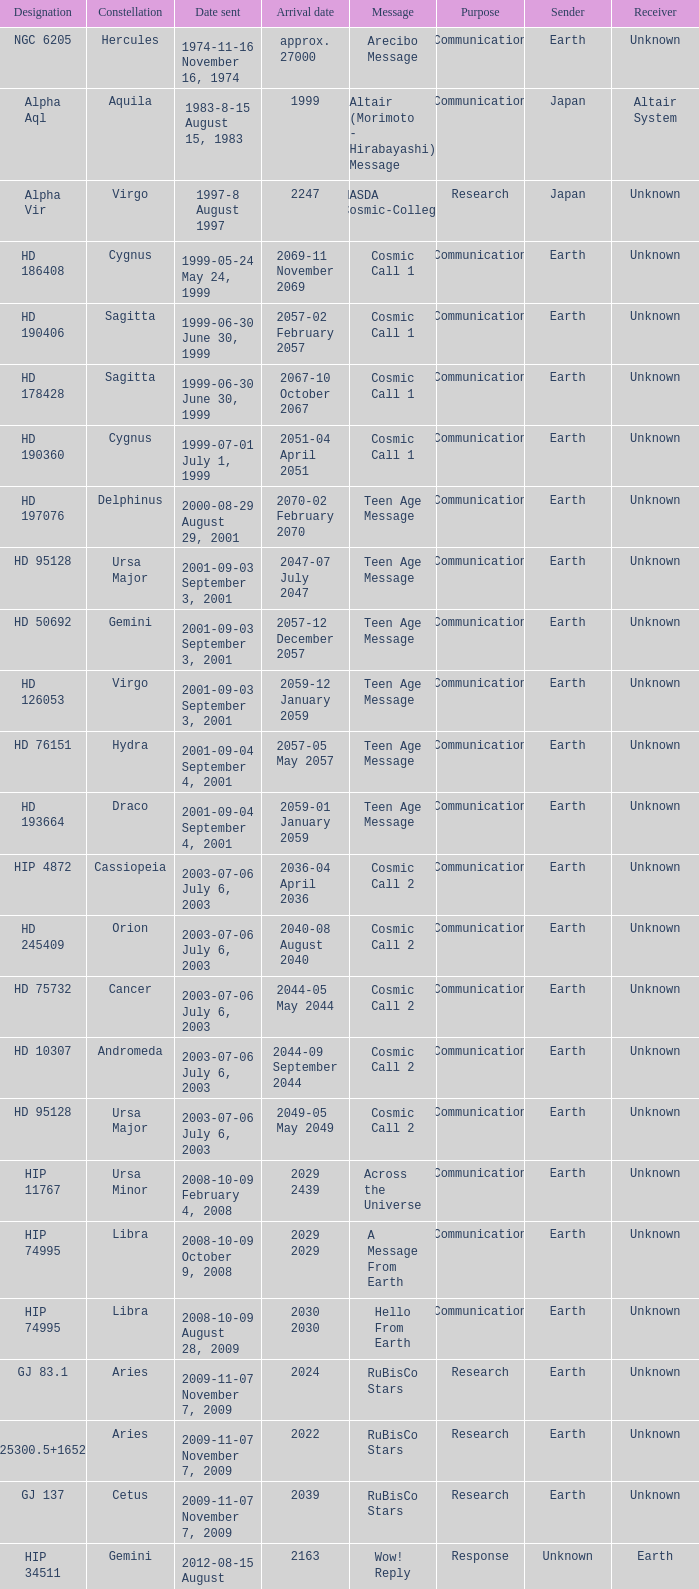Where is Hip 4872? Cassiopeia. 